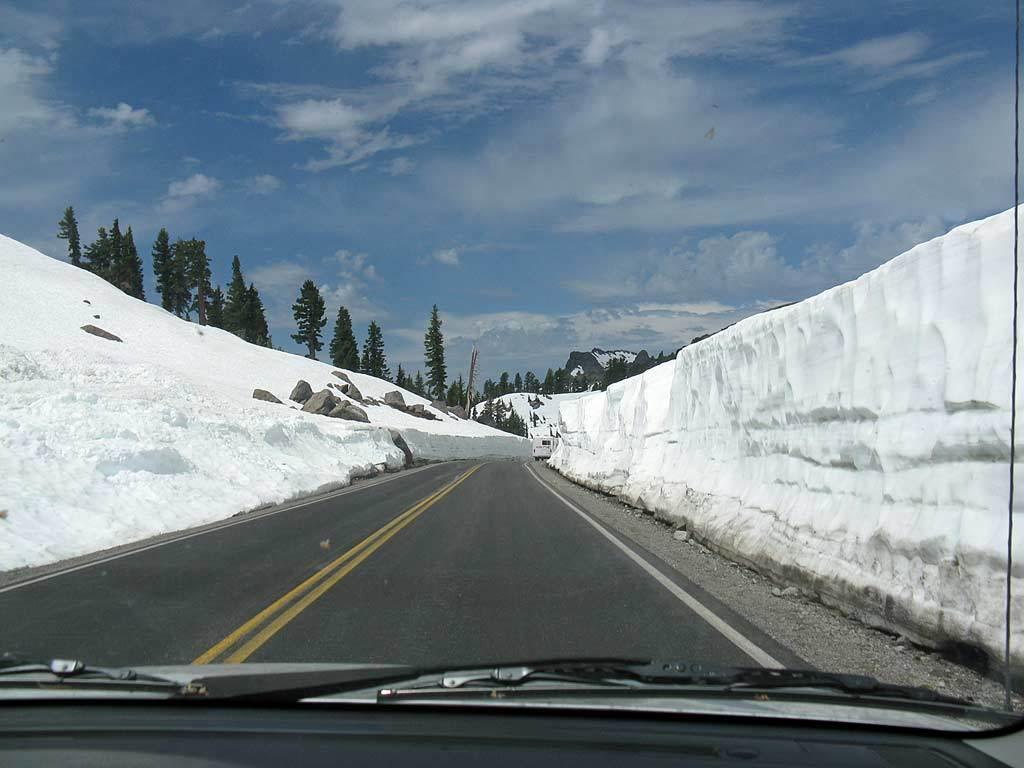What is the source of the image? The image has been captured from a vehicle. What can be seen on the road in the image? There is an empty road visible in the image. What natural features are present in the background of the image? Snow mountains are present beside the trees in the image. What type of vegetation is visible in the image? Trees are visible in the image. Can you see any sugar on the road in the image? There is no sugar present on the road in the image. Is there a rifle visible in the image? There is no rifle present in the image. 